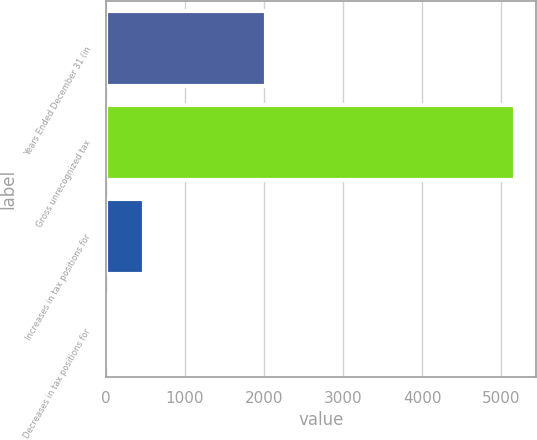Convert chart to OTSL. <chart><loc_0><loc_0><loc_500><loc_500><bar_chart><fcel>Years Ended December 31 (in<fcel>Gross unrecognized tax<fcel>Increases in tax positions for<fcel>Decreases in tax positions for<nl><fcel>2018<fcel>5177.3<fcel>476.3<fcel>6<nl></chart> 